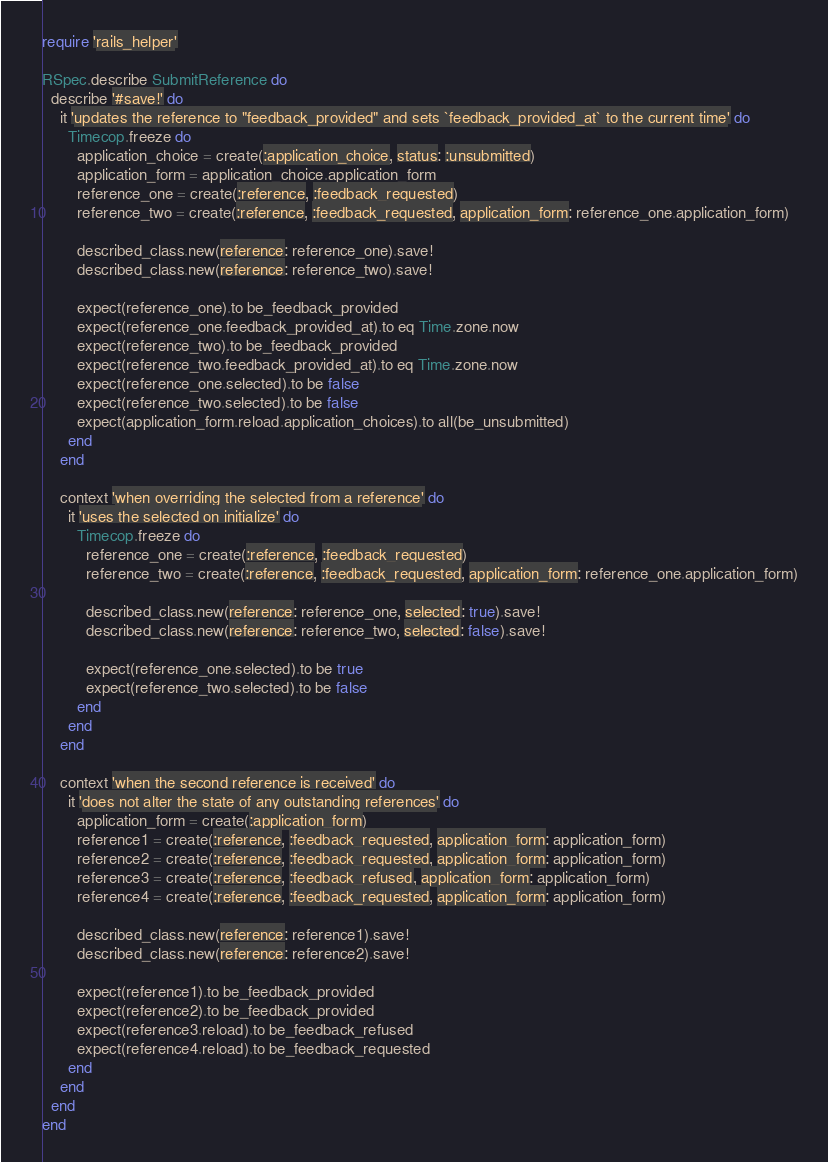Convert code to text. <code><loc_0><loc_0><loc_500><loc_500><_Ruby_>require 'rails_helper'

RSpec.describe SubmitReference do
  describe '#save!' do
    it 'updates the reference to "feedback_provided" and sets `feedback_provided_at` to the current time' do
      Timecop.freeze do
        application_choice = create(:application_choice, status: :unsubmitted)
        application_form = application_choice.application_form
        reference_one = create(:reference, :feedback_requested)
        reference_two = create(:reference, :feedback_requested, application_form: reference_one.application_form)

        described_class.new(reference: reference_one).save!
        described_class.new(reference: reference_two).save!

        expect(reference_one).to be_feedback_provided
        expect(reference_one.feedback_provided_at).to eq Time.zone.now
        expect(reference_two).to be_feedback_provided
        expect(reference_two.feedback_provided_at).to eq Time.zone.now
        expect(reference_one.selected).to be false
        expect(reference_two.selected).to be false
        expect(application_form.reload.application_choices).to all(be_unsubmitted)
      end
    end

    context 'when overriding the selected from a reference' do
      it 'uses the selected on initialize' do
        Timecop.freeze do
          reference_one = create(:reference, :feedback_requested)
          reference_two = create(:reference, :feedback_requested, application_form: reference_one.application_form)

          described_class.new(reference: reference_one, selected: true).save!
          described_class.new(reference: reference_two, selected: false).save!

          expect(reference_one.selected).to be true
          expect(reference_two.selected).to be false
        end
      end
    end

    context 'when the second reference is received' do
      it 'does not alter the state of any outstanding references' do
        application_form = create(:application_form)
        reference1 = create(:reference, :feedback_requested, application_form: application_form)
        reference2 = create(:reference, :feedback_requested, application_form: application_form)
        reference3 = create(:reference, :feedback_refused, application_form: application_form)
        reference4 = create(:reference, :feedback_requested, application_form: application_form)

        described_class.new(reference: reference1).save!
        described_class.new(reference: reference2).save!

        expect(reference1).to be_feedback_provided
        expect(reference2).to be_feedback_provided
        expect(reference3.reload).to be_feedback_refused
        expect(reference4.reload).to be_feedback_requested
      end
    end
  end
end
</code> 